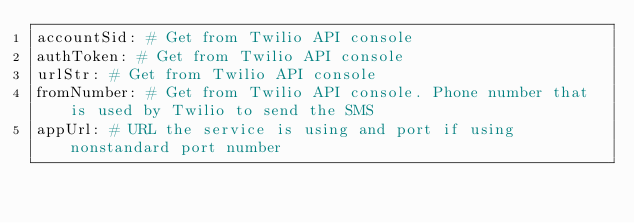Convert code to text. <code><loc_0><loc_0><loc_500><loc_500><_YAML_>accountSid: # Get from Twilio API console
authToken: # Get from Twilio API console
urlStr: # Get from Twilio API console
fromNumber: # Get from Twilio API console. Phone number that is used by Twilio to send the SMS
appUrl: # URL the service is using and port if using nonstandard port number</code> 